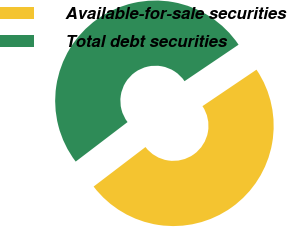Convert chart. <chart><loc_0><loc_0><loc_500><loc_500><pie_chart><fcel>Available-for-sale securities<fcel>Total debt securities<nl><fcel>49.09%<fcel>50.91%<nl></chart> 